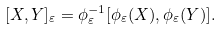Convert formula to latex. <formula><loc_0><loc_0><loc_500><loc_500>[ X , Y ] _ { \varepsilon } = \phi _ { \varepsilon } ^ { - 1 } [ \phi _ { \varepsilon } ( X ) , \phi _ { \varepsilon } ( Y ) ] .</formula> 